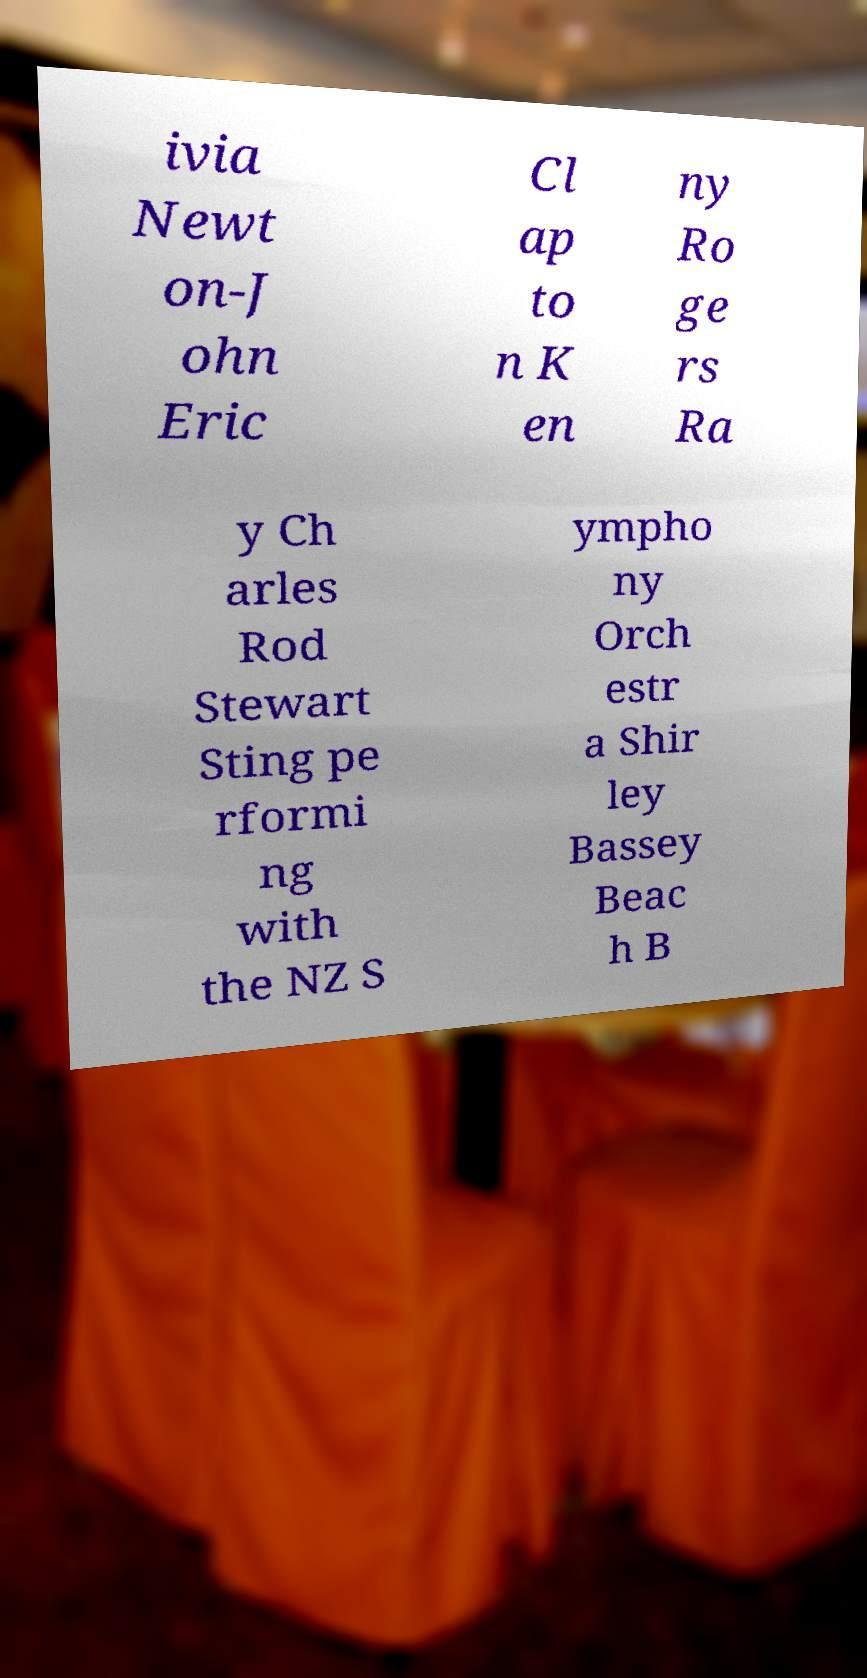For documentation purposes, I need the text within this image transcribed. Could you provide that? ivia Newt on-J ohn Eric Cl ap to n K en ny Ro ge rs Ra y Ch arles Rod Stewart Sting pe rformi ng with the NZ S ympho ny Orch estr a Shir ley Bassey Beac h B 